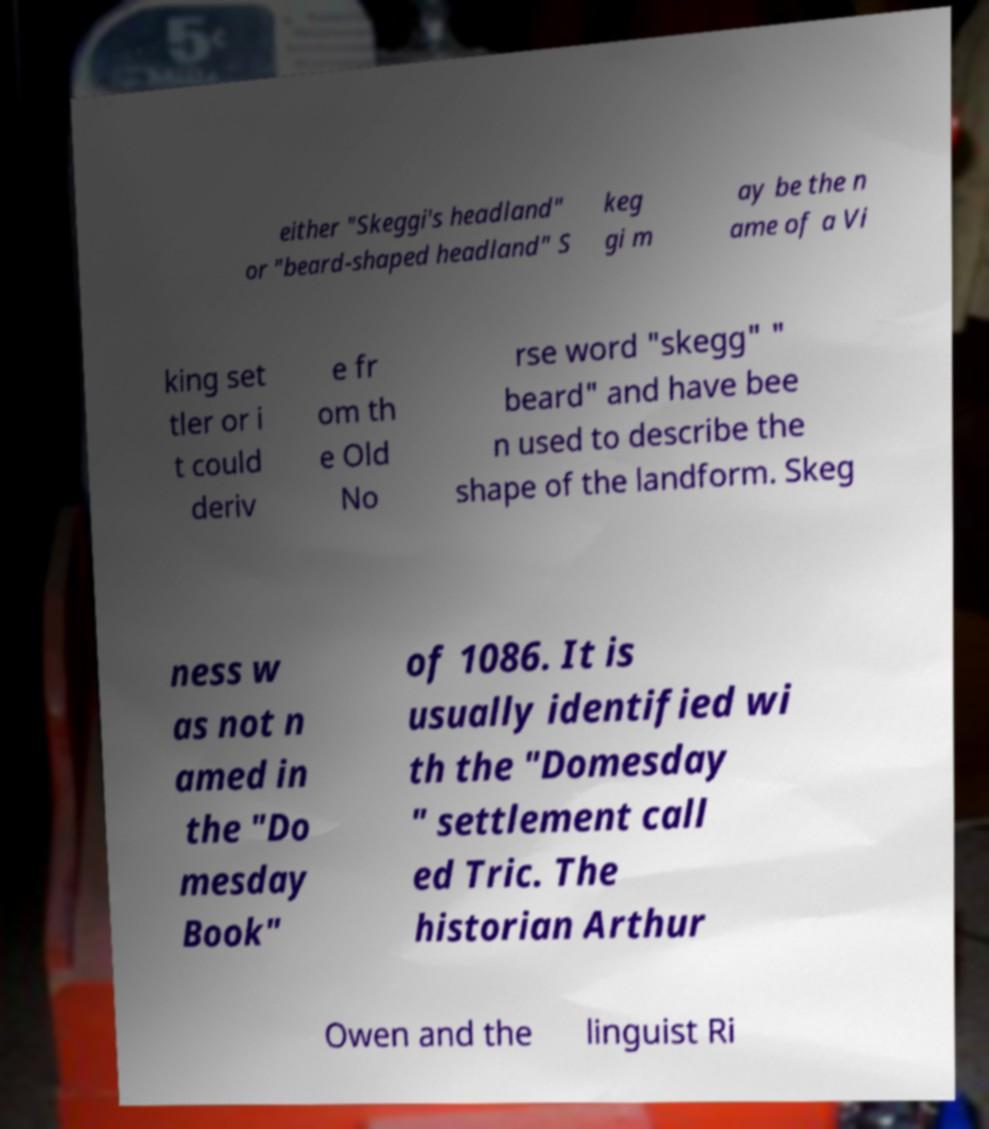Please identify and transcribe the text found in this image. either "Skeggi's headland" or "beard-shaped headland" S keg gi m ay be the n ame of a Vi king set tler or i t could deriv e fr om th e Old No rse word "skegg" " beard" and have bee n used to describe the shape of the landform. Skeg ness w as not n amed in the "Do mesday Book" of 1086. It is usually identified wi th the "Domesday " settlement call ed Tric. The historian Arthur Owen and the linguist Ri 